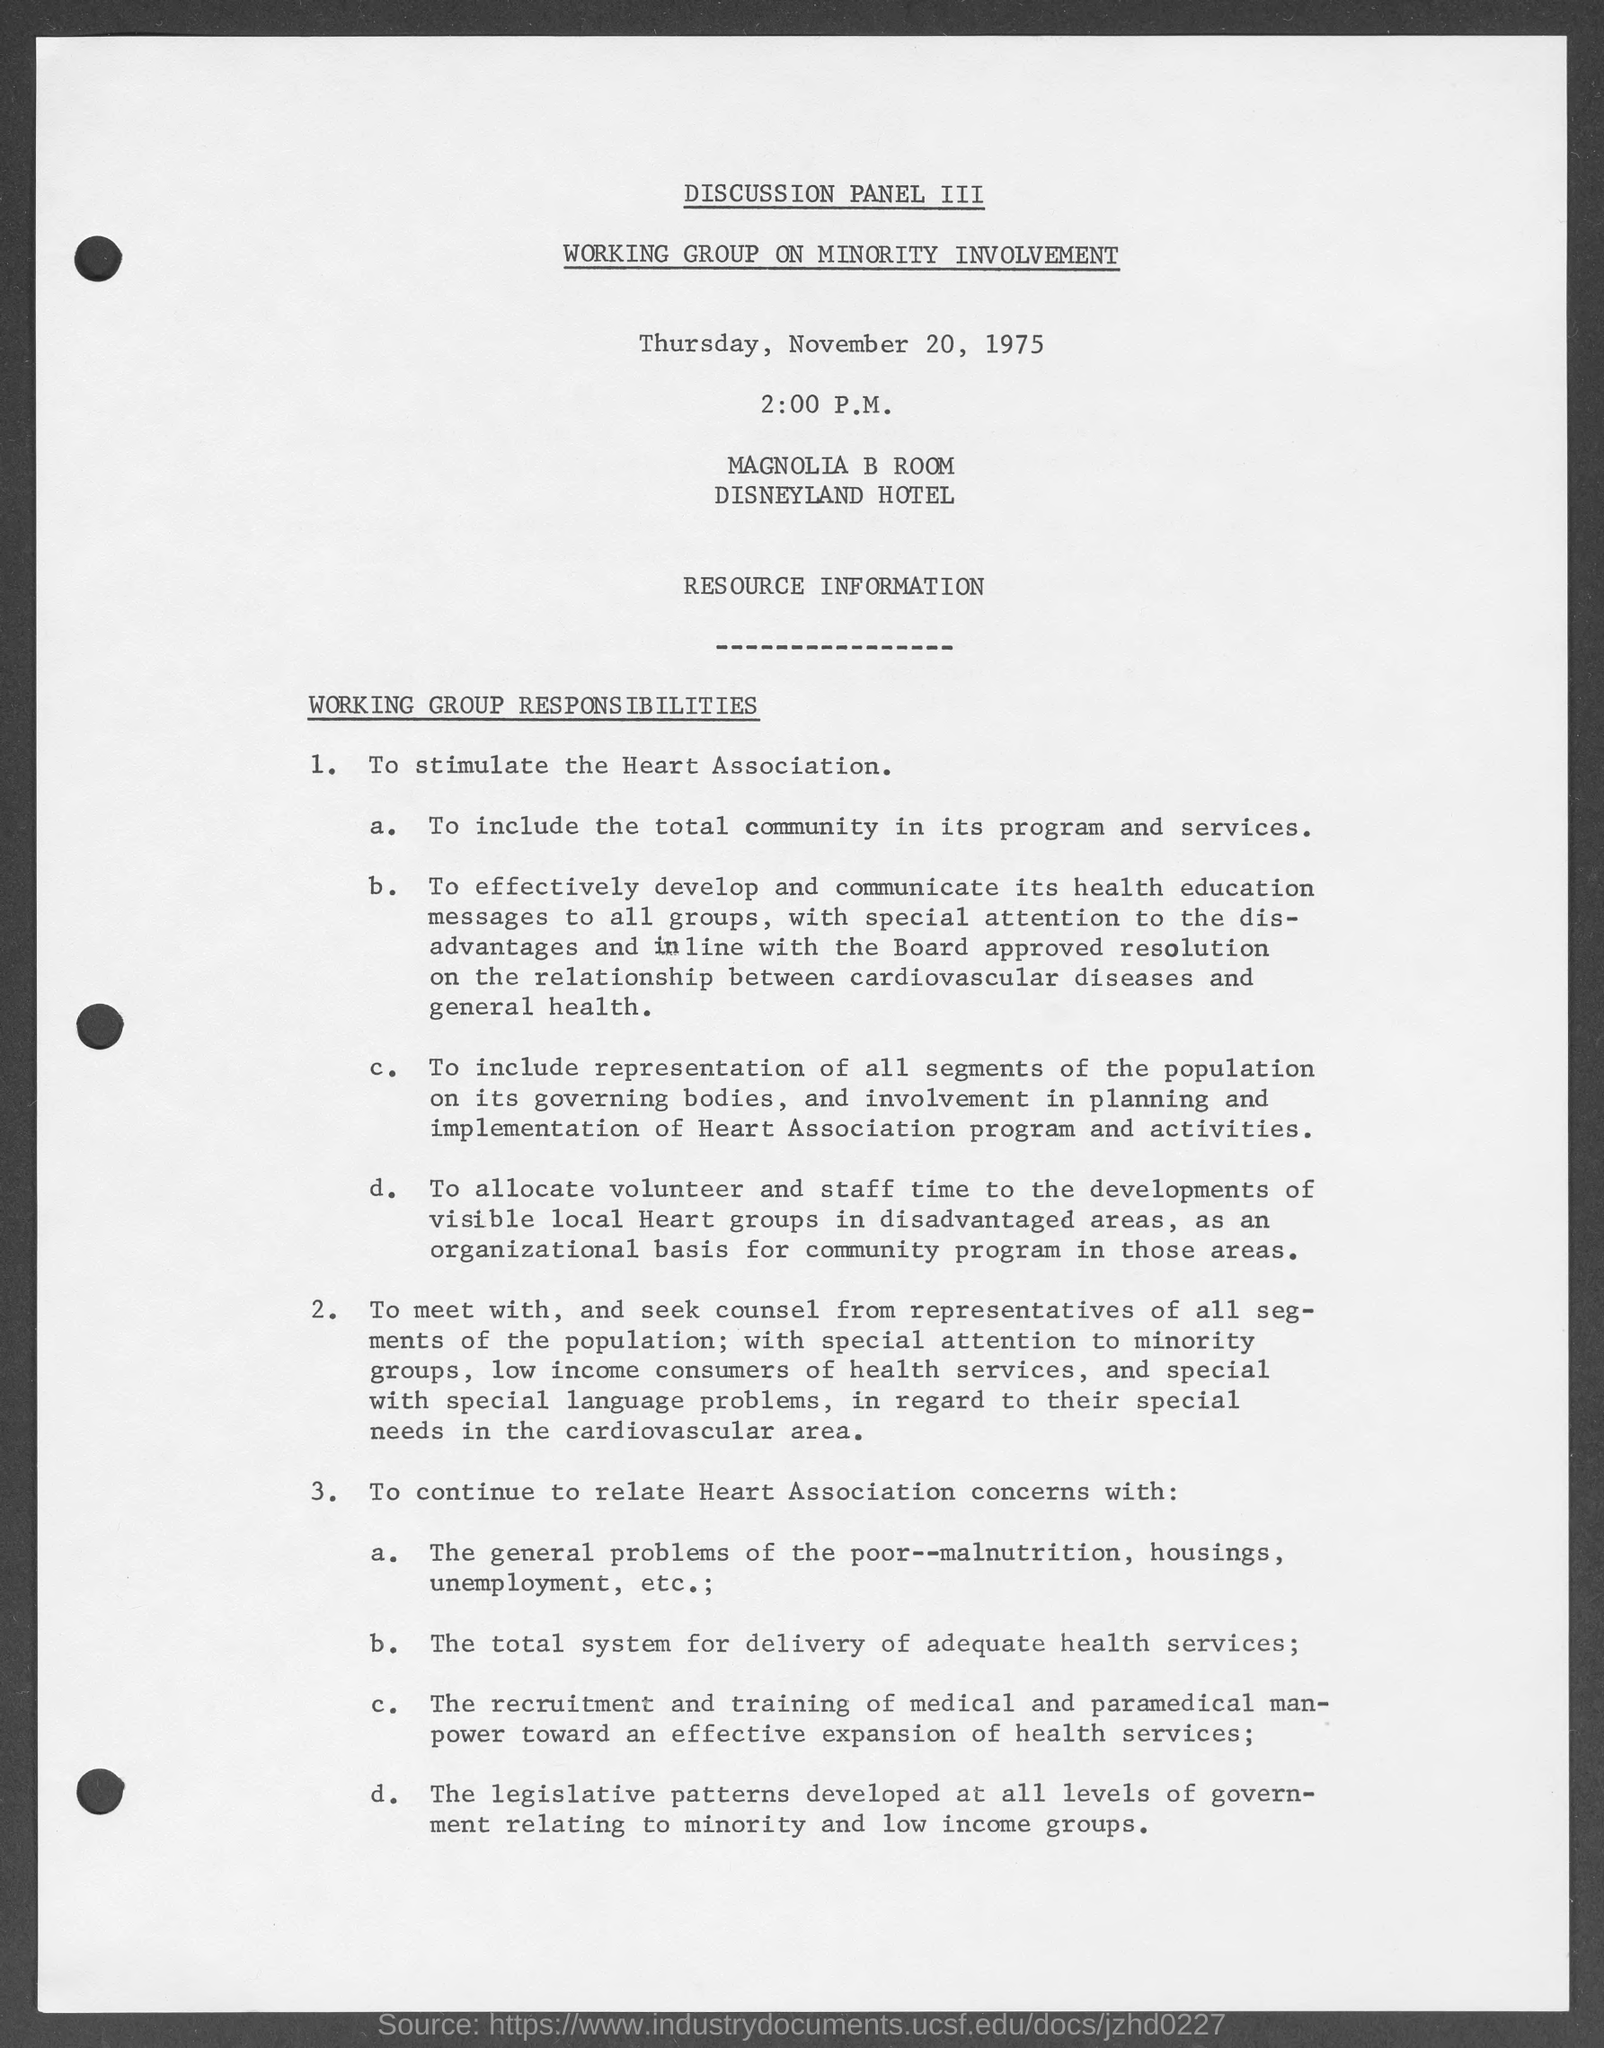What is the scheduled time mentioned in the given page ?
Your response must be concise. 2:00 P.M. What is the name of the hotel mentioned in the given page ?
Your response must be concise. Disneyland hotel. 